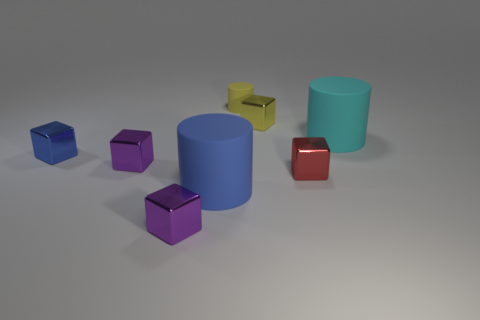What material is the cylinder that is the same size as the red thing?
Provide a succinct answer. Rubber. How many other objects are the same material as the small cylinder?
Your answer should be very brief. 2. How many blue blocks are to the left of the blue metal block?
Your answer should be very brief. 0. What number of cubes are metal things or red things?
Provide a succinct answer. 5. There is a matte cylinder that is in front of the small yellow matte cylinder and on the left side of the yellow shiny object; how big is it?
Offer a very short reply. Large. How many other objects are there of the same color as the tiny rubber thing?
Offer a very short reply. 1. Is the tiny cylinder made of the same material as the small red thing to the left of the cyan matte thing?
Provide a succinct answer. No. How many objects are big cylinders to the left of the red block or large purple matte things?
Give a very brief answer. 1. There is a matte object that is both in front of the yellow rubber cylinder and right of the large blue object; what is its shape?
Provide a succinct answer. Cylinder. Are there any other things that have the same size as the red block?
Keep it short and to the point. Yes. 